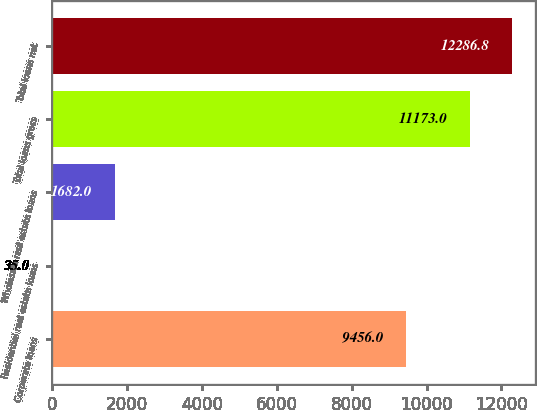Convert chart to OTSL. <chart><loc_0><loc_0><loc_500><loc_500><bar_chart><fcel>Corporate loans<fcel>Residential real estate loans<fcel>Wholesale real estate loans<fcel>Total loans gross<fcel>Total loans net<nl><fcel>9456<fcel>35<fcel>1682<fcel>11173<fcel>12286.8<nl></chart> 